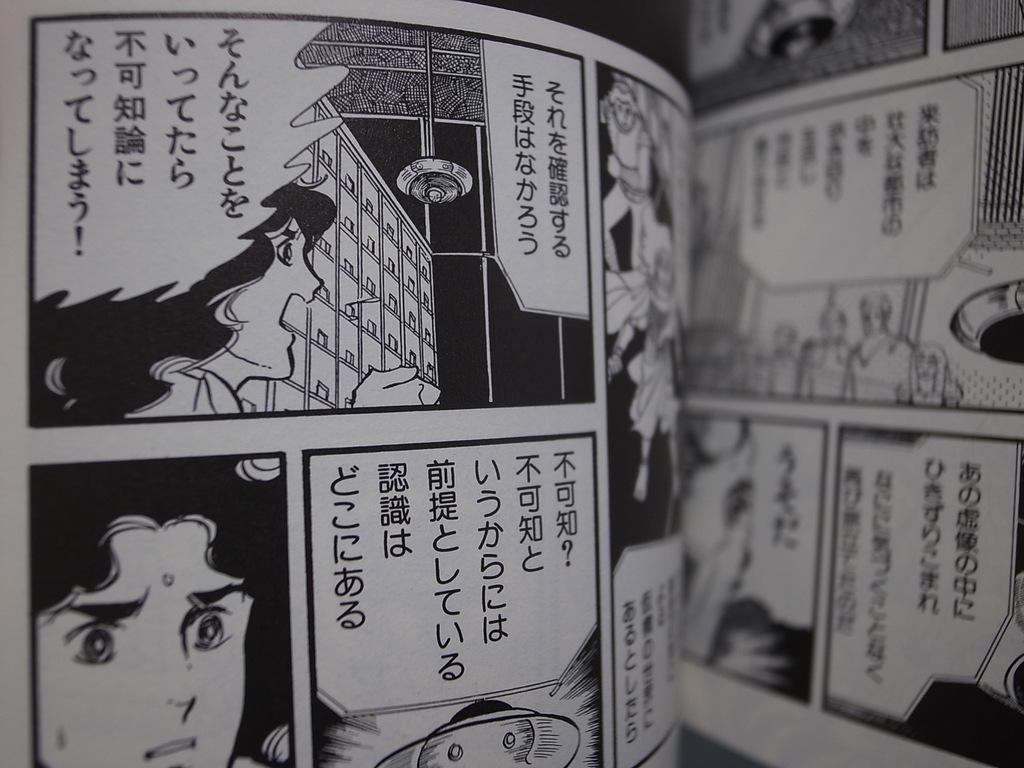What is the color scheme of the paper in the image? The paper in the image is black and white. What is featured on the paper besides text? The paper has pictures on it. What can be read on the paper in the image? The paper has text on it. How would you describe the appearance of the paper in the image? The paper is slightly blurred. Are there any other papers visible in the image? Yes, there is another paper visible in the image. What type of collar is being worn by the kettle in the image? There is no kettle or collar present in the image. How does the anger in the image manifest itself? There is no indication of anger in the image; it features a black and white paper with pictures and text. 